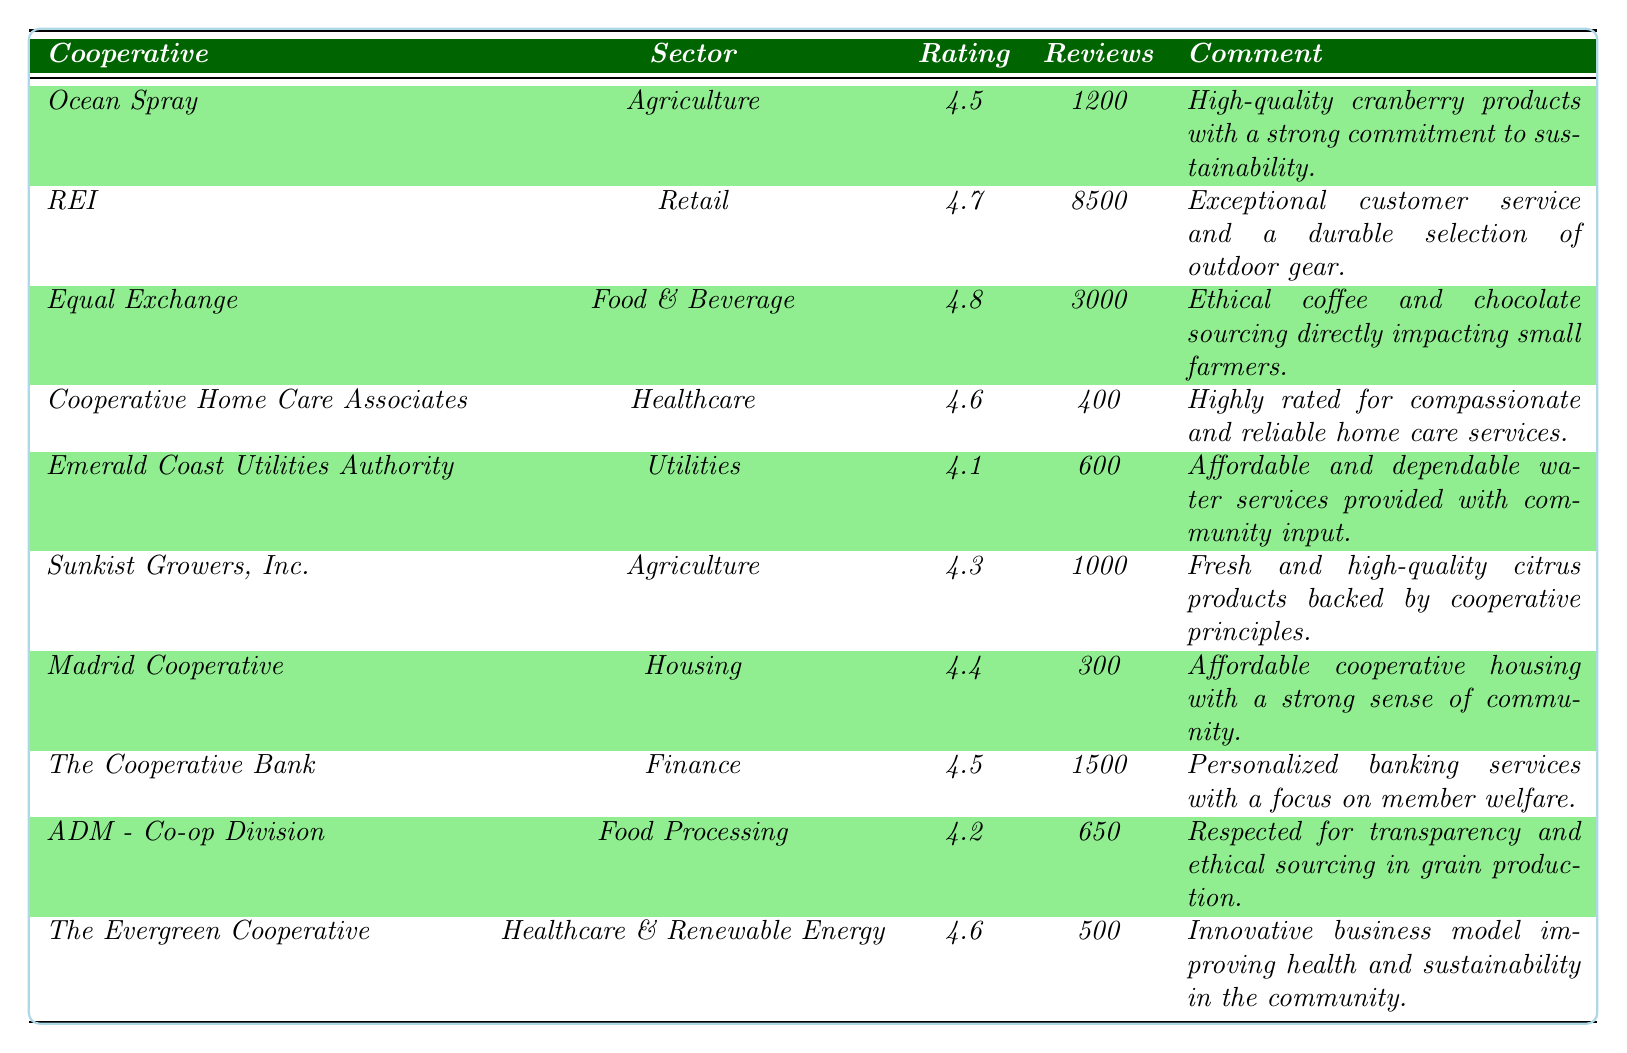What is the consumer satisfaction rating for REI? The table indicates that REI has a consumer satisfaction rating listed in the corresponding row, which is 4.7.
Answer: 4.7 Which cooperative business has the highest consumer satisfaction rating? By examining the ratings, we see Equal Exchange with a rating of 4.8 is the highest.
Answer: Equal Exchange How many reviews did Ocean Spray receive? The table shows that Ocean Spray received a total of 1200 reviews.
Answer: 1200 What is the average consumer satisfaction rating of all cooperatives listed? We total the ratings: (4.5 + 4.7 + 4.8 + 4.6 + 4.1 + 4.3 + 4.4 + 4.5 + 4.2 + 4.6) = 46.7, then divide by 10 (the number of cooperatives), which gives us 46.7 / 10 = 4.67.
Answer: 4.67 Is the consumer satisfaction rating for Cooperative Home Care Associates higher than that of The Cooperative Bank? Cooperative Home Care Associates has a rating of 4.6, while The Cooperative Bank's rating is 4.5, thus 4.6 > 4.5.
Answer: Yes Which sector has the lowest consumer satisfaction rating among the cooperatives? Comparative analysis shows that the Utilities sector, represented by Emerald Coast Utilities Authority with a rating of 4.1, is the lowest.
Answer: Utilities Calculate the difference in consumer satisfaction ratings between Equal Exchange and Sunkist Growers, Inc. Equal Exchange has a rating of 4.8 and Sunkist Growers, Inc. has a rating of 4.3; the difference is 4.8 - 4.3 = 0.5.
Answer: 0.5 Are there more reviews for The Cooperative Bank than for Cooperative Home Care Associates? The Cooperative Bank has 1500 reviews, while Cooperative Home Care Associates has 400; hence, 1500 > 400.
Answer: Yes What proportion of the reviews do Equal Exchange's reviews represent out of the total reviews from all cooperatives? The total reviews are 1200 + 8500 + 3000 + 400 + 600 + 1000 + 300 + 1500 + 650 + 500 = 12,000. Equal Exchange has 3000 reviews, so the proportion is 3000 / 12000 = 0.25 or 25%.
Answer: 25% Which cooperative has a focus on ethical sourcing in food processing and what is its rating? Archer Daniels Midland Company (ADM) - Co-op Division is noted for transparency and ethical sourcing in grain production with a rating of 4.2.
Answer: ADM - Co-op Division, 4.2 